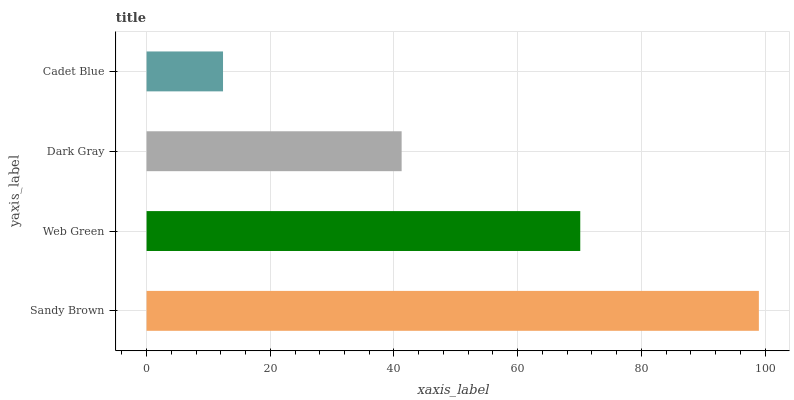Is Cadet Blue the minimum?
Answer yes or no. Yes. Is Sandy Brown the maximum?
Answer yes or no. Yes. Is Web Green the minimum?
Answer yes or no. No. Is Web Green the maximum?
Answer yes or no. No. Is Sandy Brown greater than Web Green?
Answer yes or no. Yes. Is Web Green less than Sandy Brown?
Answer yes or no. Yes. Is Web Green greater than Sandy Brown?
Answer yes or no. No. Is Sandy Brown less than Web Green?
Answer yes or no. No. Is Web Green the high median?
Answer yes or no. Yes. Is Dark Gray the low median?
Answer yes or no. Yes. Is Dark Gray the high median?
Answer yes or no. No. Is Web Green the low median?
Answer yes or no. No. 